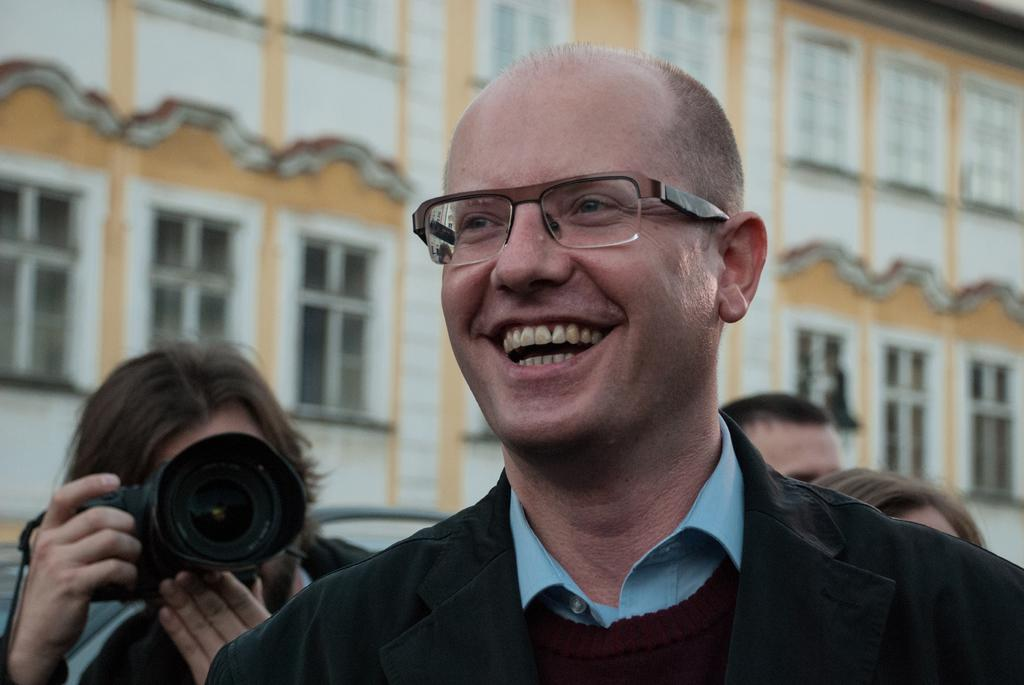What is the person in the image wearing? The person is wearing a black dress. What is the facial expression of the person in the image? The person is smiling. Can you describe the person in the background? There is another person holding a camera in the background. What is the color of the building in the background? The building in the background has a white color. How many cats can be seen touching the person in the image? There are no cats present in the image, and therefore no cats can be seen touching the person. 